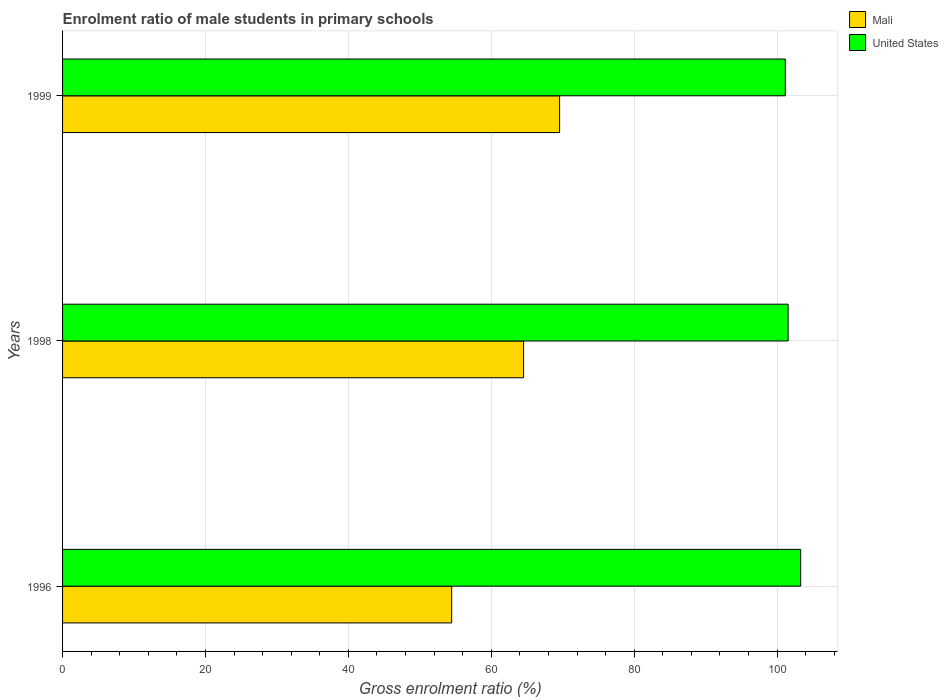How many different coloured bars are there?
Your answer should be compact. 2. How many bars are there on the 2nd tick from the bottom?
Give a very brief answer. 2. What is the enrolment ratio of male students in primary schools in United States in 1996?
Your answer should be very brief. 103.3. Across all years, what is the maximum enrolment ratio of male students in primary schools in Mali?
Your response must be concise. 69.56. Across all years, what is the minimum enrolment ratio of male students in primary schools in United States?
Your response must be concise. 101.15. What is the total enrolment ratio of male students in primary schools in Mali in the graph?
Your answer should be very brief. 188.54. What is the difference between the enrolment ratio of male students in primary schools in Mali in 1998 and that in 1999?
Offer a terse response. -5.04. What is the difference between the enrolment ratio of male students in primary schools in United States in 1998 and the enrolment ratio of male students in primary schools in Mali in 1999?
Keep it short and to the point. 31.98. What is the average enrolment ratio of male students in primary schools in United States per year?
Provide a succinct answer. 102. In the year 1996, what is the difference between the enrolment ratio of male students in primary schools in Mali and enrolment ratio of male students in primary schools in United States?
Provide a short and direct response. -48.84. What is the ratio of the enrolment ratio of male students in primary schools in United States in 1996 to that in 1998?
Provide a succinct answer. 1.02. Is the difference between the enrolment ratio of male students in primary schools in Mali in 1998 and 1999 greater than the difference between the enrolment ratio of male students in primary schools in United States in 1998 and 1999?
Offer a very short reply. No. What is the difference between the highest and the second highest enrolment ratio of male students in primary schools in Mali?
Make the answer very short. 5.04. What is the difference between the highest and the lowest enrolment ratio of male students in primary schools in Mali?
Make the answer very short. 15.11. What does the 2nd bar from the top in 1996 represents?
Make the answer very short. Mali. What does the 1st bar from the bottom in 1996 represents?
Offer a terse response. Mali. How many years are there in the graph?
Your answer should be very brief. 3. What is the difference between two consecutive major ticks on the X-axis?
Keep it short and to the point. 20. Are the values on the major ticks of X-axis written in scientific E-notation?
Give a very brief answer. No. Does the graph contain any zero values?
Offer a terse response. No. How many legend labels are there?
Ensure brevity in your answer.  2. What is the title of the graph?
Your answer should be compact. Enrolment ratio of male students in primary schools. Does "Nigeria" appear as one of the legend labels in the graph?
Make the answer very short. No. What is the Gross enrolment ratio (%) in Mali in 1996?
Offer a terse response. 54.46. What is the Gross enrolment ratio (%) in United States in 1996?
Offer a very short reply. 103.3. What is the Gross enrolment ratio (%) of Mali in 1998?
Provide a short and direct response. 64.52. What is the Gross enrolment ratio (%) of United States in 1998?
Your answer should be compact. 101.54. What is the Gross enrolment ratio (%) of Mali in 1999?
Offer a very short reply. 69.56. What is the Gross enrolment ratio (%) in United States in 1999?
Offer a very short reply. 101.15. Across all years, what is the maximum Gross enrolment ratio (%) of Mali?
Provide a short and direct response. 69.56. Across all years, what is the maximum Gross enrolment ratio (%) of United States?
Ensure brevity in your answer.  103.3. Across all years, what is the minimum Gross enrolment ratio (%) of Mali?
Ensure brevity in your answer.  54.46. Across all years, what is the minimum Gross enrolment ratio (%) in United States?
Your answer should be compact. 101.15. What is the total Gross enrolment ratio (%) in Mali in the graph?
Provide a succinct answer. 188.54. What is the total Gross enrolment ratio (%) of United States in the graph?
Offer a terse response. 305.99. What is the difference between the Gross enrolment ratio (%) in Mali in 1996 and that in 1998?
Your response must be concise. -10.07. What is the difference between the Gross enrolment ratio (%) in United States in 1996 and that in 1998?
Give a very brief answer. 1.75. What is the difference between the Gross enrolment ratio (%) in Mali in 1996 and that in 1999?
Provide a short and direct response. -15.11. What is the difference between the Gross enrolment ratio (%) of United States in 1996 and that in 1999?
Ensure brevity in your answer.  2.15. What is the difference between the Gross enrolment ratio (%) in Mali in 1998 and that in 1999?
Offer a very short reply. -5.04. What is the difference between the Gross enrolment ratio (%) of United States in 1998 and that in 1999?
Your response must be concise. 0.39. What is the difference between the Gross enrolment ratio (%) of Mali in 1996 and the Gross enrolment ratio (%) of United States in 1998?
Give a very brief answer. -47.09. What is the difference between the Gross enrolment ratio (%) in Mali in 1996 and the Gross enrolment ratio (%) in United States in 1999?
Offer a very short reply. -46.69. What is the difference between the Gross enrolment ratio (%) of Mali in 1998 and the Gross enrolment ratio (%) of United States in 1999?
Ensure brevity in your answer.  -36.63. What is the average Gross enrolment ratio (%) in Mali per year?
Ensure brevity in your answer.  62.85. What is the average Gross enrolment ratio (%) of United States per year?
Offer a very short reply. 102. In the year 1996, what is the difference between the Gross enrolment ratio (%) of Mali and Gross enrolment ratio (%) of United States?
Keep it short and to the point. -48.84. In the year 1998, what is the difference between the Gross enrolment ratio (%) in Mali and Gross enrolment ratio (%) in United States?
Your answer should be very brief. -37.02. In the year 1999, what is the difference between the Gross enrolment ratio (%) of Mali and Gross enrolment ratio (%) of United States?
Provide a short and direct response. -31.59. What is the ratio of the Gross enrolment ratio (%) in Mali in 1996 to that in 1998?
Your answer should be compact. 0.84. What is the ratio of the Gross enrolment ratio (%) in United States in 1996 to that in 1998?
Give a very brief answer. 1.02. What is the ratio of the Gross enrolment ratio (%) of Mali in 1996 to that in 1999?
Your answer should be compact. 0.78. What is the ratio of the Gross enrolment ratio (%) in United States in 1996 to that in 1999?
Offer a terse response. 1.02. What is the ratio of the Gross enrolment ratio (%) of Mali in 1998 to that in 1999?
Your response must be concise. 0.93. What is the difference between the highest and the second highest Gross enrolment ratio (%) of Mali?
Your answer should be compact. 5.04. What is the difference between the highest and the second highest Gross enrolment ratio (%) in United States?
Offer a terse response. 1.75. What is the difference between the highest and the lowest Gross enrolment ratio (%) of Mali?
Your answer should be very brief. 15.11. What is the difference between the highest and the lowest Gross enrolment ratio (%) of United States?
Provide a succinct answer. 2.15. 